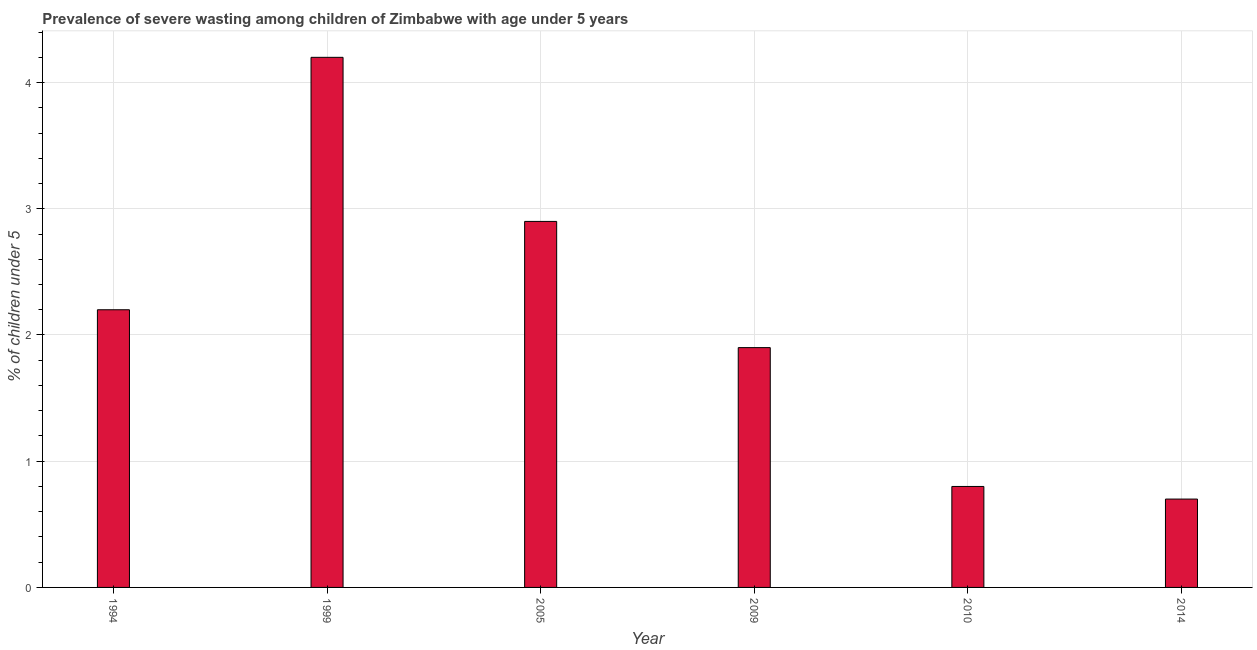Does the graph contain any zero values?
Your answer should be compact. No. What is the title of the graph?
Your answer should be compact. Prevalence of severe wasting among children of Zimbabwe with age under 5 years. What is the label or title of the Y-axis?
Make the answer very short.  % of children under 5. What is the prevalence of severe wasting in 2005?
Provide a succinct answer. 2.9. Across all years, what is the maximum prevalence of severe wasting?
Ensure brevity in your answer.  4.2. Across all years, what is the minimum prevalence of severe wasting?
Your answer should be compact. 0.7. In which year was the prevalence of severe wasting minimum?
Offer a terse response. 2014. What is the sum of the prevalence of severe wasting?
Provide a succinct answer. 12.7. What is the average prevalence of severe wasting per year?
Provide a short and direct response. 2.12. What is the median prevalence of severe wasting?
Your response must be concise. 2.05. In how many years, is the prevalence of severe wasting greater than 2 %?
Your answer should be very brief. 3. Do a majority of the years between 2014 and 2005 (inclusive) have prevalence of severe wasting greater than 2 %?
Your answer should be compact. Yes. What is the ratio of the prevalence of severe wasting in 2005 to that in 2010?
Your response must be concise. 3.62. What is the difference between the highest and the second highest prevalence of severe wasting?
Give a very brief answer. 1.3. Is the sum of the prevalence of severe wasting in 2009 and 2010 greater than the maximum prevalence of severe wasting across all years?
Give a very brief answer. No. In how many years, is the prevalence of severe wasting greater than the average prevalence of severe wasting taken over all years?
Keep it short and to the point. 3. How many years are there in the graph?
Ensure brevity in your answer.  6. What is the difference between two consecutive major ticks on the Y-axis?
Keep it short and to the point. 1. Are the values on the major ticks of Y-axis written in scientific E-notation?
Your response must be concise. No. What is the  % of children under 5 in 1994?
Your answer should be compact. 2.2. What is the  % of children under 5 in 1999?
Your answer should be compact. 4.2. What is the  % of children under 5 of 2005?
Provide a succinct answer. 2.9. What is the  % of children under 5 of 2009?
Keep it short and to the point. 1.9. What is the  % of children under 5 in 2010?
Ensure brevity in your answer.  0.8. What is the  % of children under 5 of 2014?
Ensure brevity in your answer.  0.7. What is the difference between the  % of children under 5 in 1994 and 2005?
Offer a terse response. -0.7. What is the difference between the  % of children under 5 in 1994 and 2009?
Provide a succinct answer. 0.3. What is the difference between the  % of children under 5 in 1994 and 2014?
Your response must be concise. 1.5. What is the difference between the  % of children under 5 in 1999 and 2009?
Offer a terse response. 2.3. What is the difference between the  % of children under 5 in 1999 and 2010?
Offer a very short reply. 3.4. What is the difference between the  % of children under 5 in 2009 and 2010?
Make the answer very short. 1.1. What is the difference between the  % of children under 5 in 2009 and 2014?
Make the answer very short. 1.2. What is the ratio of the  % of children under 5 in 1994 to that in 1999?
Make the answer very short. 0.52. What is the ratio of the  % of children under 5 in 1994 to that in 2005?
Offer a very short reply. 0.76. What is the ratio of the  % of children under 5 in 1994 to that in 2009?
Your answer should be very brief. 1.16. What is the ratio of the  % of children under 5 in 1994 to that in 2010?
Make the answer very short. 2.75. What is the ratio of the  % of children under 5 in 1994 to that in 2014?
Give a very brief answer. 3.14. What is the ratio of the  % of children under 5 in 1999 to that in 2005?
Offer a very short reply. 1.45. What is the ratio of the  % of children under 5 in 1999 to that in 2009?
Provide a short and direct response. 2.21. What is the ratio of the  % of children under 5 in 1999 to that in 2010?
Give a very brief answer. 5.25. What is the ratio of the  % of children under 5 in 1999 to that in 2014?
Your response must be concise. 6. What is the ratio of the  % of children under 5 in 2005 to that in 2009?
Offer a very short reply. 1.53. What is the ratio of the  % of children under 5 in 2005 to that in 2010?
Offer a terse response. 3.62. What is the ratio of the  % of children under 5 in 2005 to that in 2014?
Keep it short and to the point. 4.14. What is the ratio of the  % of children under 5 in 2009 to that in 2010?
Offer a terse response. 2.38. What is the ratio of the  % of children under 5 in 2009 to that in 2014?
Give a very brief answer. 2.71. What is the ratio of the  % of children under 5 in 2010 to that in 2014?
Provide a succinct answer. 1.14. 